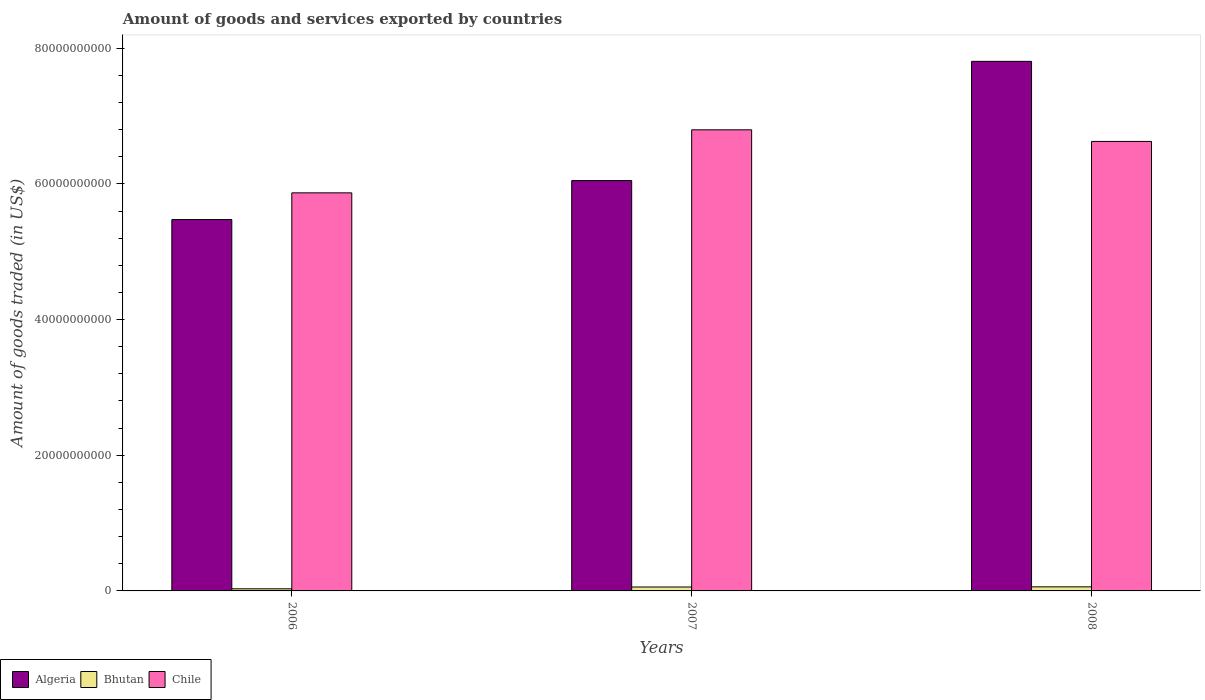Are the number of bars on each tick of the X-axis equal?
Your answer should be very brief. Yes. How many bars are there on the 1st tick from the left?
Give a very brief answer. 3. In how many cases, is the number of bars for a given year not equal to the number of legend labels?
Offer a terse response. 0. What is the total amount of goods and services exported in Chile in 2007?
Offer a very short reply. 6.80e+1. Across all years, what is the maximum total amount of goods and services exported in Chile?
Your answer should be compact. 6.80e+1. Across all years, what is the minimum total amount of goods and services exported in Chile?
Your response must be concise. 5.87e+1. What is the total total amount of goods and services exported in Algeria in the graph?
Offer a terse response. 1.93e+11. What is the difference between the total amount of goods and services exported in Chile in 2007 and that in 2008?
Provide a succinct answer. 1.71e+09. What is the difference between the total amount of goods and services exported in Algeria in 2007 and the total amount of goods and services exported in Chile in 2008?
Ensure brevity in your answer.  -5.77e+09. What is the average total amount of goods and services exported in Bhutan per year?
Keep it short and to the point. 4.96e+08. In the year 2007, what is the difference between the total amount of goods and services exported in Algeria and total amount of goods and services exported in Chile?
Give a very brief answer. -7.48e+09. What is the ratio of the total amount of goods and services exported in Algeria in 2006 to that in 2008?
Your answer should be very brief. 0.7. Is the difference between the total amount of goods and services exported in Algeria in 2006 and 2008 greater than the difference between the total amount of goods and services exported in Chile in 2006 and 2008?
Give a very brief answer. No. What is the difference between the highest and the second highest total amount of goods and services exported in Algeria?
Your response must be concise. 1.76e+1. What is the difference between the highest and the lowest total amount of goods and services exported in Algeria?
Offer a terse response. 2.33e+1. Is the sum of the total amount of goods and services exported in Bhutan in 2007 and 2008 greater than the maximum total amount of goods and services exported in Algeria across all years?
Keep it short and to the point. No. What does the 1st bar from the left in 2007 represents?
Your response must be concise. Algeria. What does the 3rd bar from the right in 2008 represents?
Keep it short and to the point. Algeria. How many bars are there?
Provide a short and direct response. 9. What is the difference between two consecutive major ticks on the Y-axis?
Provide a succinct answer. 2.00e+1. How many legend labels are there?
Provide a short and direct response. 3. How are the legend labels stacked?
Offer a very short reply. Horizontal. What is the title of the graph?
Provide a succinct answer. Amount of goods and services exported by countries. What is the label or title of the Y-axis?
Your answer should be very brief. Amount of goods traded (in US$). What is the Amount of goods traded (in US$) in Algeria in 2006?
Your response must be concise. 5.47e+1. What is the Amount of goods traded (in US$) of Bhutan in 2006?
Your response must be concise. 3.12e+08. What is the Amount of goods traded (in US$) of Chile in 2006?
Provide a short and direct response. 5.87e+1. What is the Amount of goods traded (in US$) of Algeria in 2007?
Your answer should be very brief. 6.05e+1. What is the Amount of goods traded (in US$) of Bhutan in 2007?
Give a very brief answer. 5.77e+08. What is the Amount of goods traded (in US$) in Chile in 2007?
Your answer should be very brief. 6.80e+1. What is the Amount of goods traded (in US$) of Algeria in 2008?
Make the answer very short. 7.81e+1. What is the Amount of goods traded (in US$) in Bhutan in 2008?
Make the answer very short. 5.99e+08. What is the Amount of goods traded (in US$) in Chile in 2008?
Your answer should be compact. 6.63e+1. Across all years, what is the maximum Amount of goods traded (in US$) in Algeria?
Ensure brevity in your answer.  7.81e+1. Across all years, what is the maximum Amount of goods traded (in US$) of Bhutan?
Keep it short and to the point. 5.99e+08. Across all years, what is the maximum Amount of goods traded (in US$) of Chile?
Your answer should be compact. 6.80e+1. Across all years, what is the minimum Amount of goods traded (in US$) in Algeria?
Make the answer very short. 5.47e+1. Across all years, what is the minimum Amount of goods traded (in US$) in Bhutan?
Your response must be concise. 3.12e+08. Across all years, what is the minimum Amount of goods traded (in US$) of Chile?
Ensure brevity in your answer.  5.87e+1. What is the total Amount of goods traded (in US$) of Algeria in the graph?
Provide a short and direct response. 1.93e+11. What is the total Amount of goods traded (in US$) of Bhutan in the graph?
Your answer should be compact. 1.49e+09. What is the total Amount of goods traded (in US$) in Chile in the graph?
Give a very brief answer. 1.93e+11. What is the difference between the Amount of goods traded (in US$) in Algeria in 2006 and that in 2007?
Your answer should be very brief. -5.75e+09. What is the difference between the Amount of goods traded (in US$) of Bhutan in 2006 and that in 2007?
Make the answer very short. -2.65e+08. What is the difference between the Amount of goods traded (in US$) in Chile in 2006 and that in 2007?
Provide a succinct answer. -9.29e+09. What is the difference between the Amount of goods traded (in US$) in Algeria in 2006 and that in 2008?
Offer a terse response. -2.33e+1. What is the difference between the Amount of goods traded (in US$) of Bhutan in 2006 and that in 2008?
Offer a very short reply. -2.87e+08. What is the difference between the Amount of goods traded (in US$) in Chile in 2006 and that in 2008?
Keep it short and to the point. -7.58e+09. What is the difference between the Amount of goods traded (in US$) of Algeria in 2007 and that in 2008?
Provide a short and direct response. -1.76e+1. What is the difference between the Amount of goods traded (in US$) of Bhutan in 2007 and that in 2008?
Offer a very short reply. -2.23e+07. What is the difference between the Amount of goods traded (in US$) in Chile in 2007 and that in 2008?
Your answer should be compact. 1.71e+09. What is the difference between the Amount of goods traded (in US$) in Algeria in 2006 and the Amount of goods traded (in US$) in Bhutan in 2007?
Offer a terse response. 5.42e+1. What is the difference between the Amount of goods traded (in US$) in Algeria in 2006 and the Amount of goods traded (in US$) in Chile in 2007?
Provide a succinct answer. -1.32e+1. What is the difference between the Amount of goods traded (in US$) of Bhutan in 2006 and the Amount of goods traded (in US$) of Chile in 2007?
Provide a short and direct response. -6.77e+1. What is the difference between the Amount of goods traded (in US$) of Algeria in 2006 and the Amount of goods traded (in US$) of Bhutan in 2008?
Provide a short and direct response. 5.41e+1. What is the difference between the Amount of goods traded (in US$) in Algeria in 2006 and the Amount of goods traded (in US$) in Chile in 2008?
Ensure brevity in your answer.  -1.15e+1. What is the difference between the Amount of goods traded (in US$) in Bhutan in 2006 and the Amount of goods traded (in US$) in Chile in 2008?
Offer a very short reply. -6.59e+1. What is the difference between the Amount of goods traded (in US$) of Algeria in 2007 and the Amount of goods traded (in US$) of Bhutan in 2008?
Keep it short and to the point. 5.99e+1. What is the difference between the Amount of goods traded (in US$) in Algeria in 2007 and the Amount of goods traded (in US$) in Chile in 2008?
Provide a succinct answer. -5.77e+09. What is the difference between the Amount of goods traded (in US$) of Bhutan in 2007 and the Amount of goods traded (in US$) of Chile in 2008?
Your answer should be very brief. -6.57e+1. What is the average Amount of goods traded (in US$) in Algeria per year?
Offer a very short reply. 6.44e+1. What is the average Amount of goods traded (in US$) of Bhutan per year?
Offer a terse response. 4.96e+08. What is the average Amount of goods traded (in US$) in Chile per year?
Keep it short and to the point. 6.43e+1. In the year 2006, what is the difference between the Amount of goods traded (in US$) of Algeria and Amount of goods traded (in US$) of Bhutan?
Provide a short and direct response. 5.44e+1. In the year 2006, what is the difference between the Amount of goods traded (in US$) in Algeria and Amount of goods traded (in US$) in Chile?
Your answer should be very brief. -3.94e+09. In the year 2006, what is the difference between the Amount of goods traded (in US$) of Bhutan and Amount of goods traded (in US$) of Chile?
Your response must be concise. -5.84e+1. In the year 2007, what is the difference between the Amount of goods traded (in US$) in Algeria and Amount of goods traded (in US$) in Bhutan?
Your answer should be very brief. 5.99e+1. In the year 2007, what is the difference between the Amount of goods traded (in US$) in Algeria and Amount of goods traded (in US$) in Chile?
Make the answer very short. -7.48e+09. In the year 2007, what is the difference between the Amount of goods traded (in US$) in Bhutan and Amount of goods traded (in US$) in Chile?
Give a very brief answer. -6.74e+1. In the year 2008, what is the difference between the Amount of goods traded (in US$) in Algeria and Amount of goods traded (in US$) in Bhutan?
Your response must be concise. 7.75e+1. In the year 2008, what is the difference between the Amount of goods traded (in US$) in Algeria and Amount of goods traded (in US$) in Chile?
Your answer should be compact. 1.18e+1. In the year 2008, what is the difference between the Amount of goods traded (in US$) in Bhutan and Amount of goods traded (in US$) in Chile?
Offer a terse response. -6.57e+1. What is the ratio of the Amount of goods traded (in US$) of Algeria in 2006 to that in 2007?
Ensure brevity in your answer.  0.9. What is the ratio of the Amount of goods traded (in US$) of Bhutan in 2006 to that in 2007?
Your response must be concise. 0.54. What is the ratio of the Amount of goods traded (in US$) of Chile in 2006 to that in 2007?
Make the answer very short. 0.86. What is the ratio of the Amount of goods traded (in US$) in Algeria in 2006 to that in 2008?
Give a very brief answer. 0.7. What is the ratio of the Amount of goods traded (in US$) of Bhutan in 2006 to that in 2008?
Your answer should be compact. 0.52. What is the ratio of the Amount of goods traded (in US$) of Chile in 2006 to that in 2008?
Make the answer very short. 0.89. What is the ratio of the Amount of goods traded (in US$) in Algeria in 2007 to that in 2008?
Give a very brief answer. 0.77. What is the ratio of the Amount of goods traded (in US$) in Bhutan in 2007 to that in 2008?
Make the answer very short. 0.96. What is the ratio of the Amount of goods traded (in US$) in Chile in 2007 to that in 2008?
Offer a very short reply. 1.03. What is the difference between the highest and the second highest Amount of goods traded (in US$) of Algeria?
Your answer should be compact. 1.76e+1. What is the difference between the highest and the second highest Amount of goods traded (in US$) in Bhutan?
Offer a very short reply. 2.23e+07. What is the difference between the highest and the second highest Amount of goods traded (in US$) in Chile?
Offer a terse response. 1.71e+09. What is the difference between the highest and the lowest Amount of goods traded (in US$) in Algeria?
Give a very brief answer. 2.33e+1. What is the difference between the highest and the lowest Amount of goods traded (in US$) of Bhutan?
Your answer should be compact. 2.87e+08. What is the difference between the highest and the lowest Amount of goods traded (in US$) of Chile?
Provide a succinct answer. 9.29e+09. 